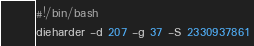Convert code to text. <code><loc_0><loc_0><loc_500><loc_500><_Bash_>#!/bin/bash
dieharder -d 207 -g 37 -S 2330937861
</code> 